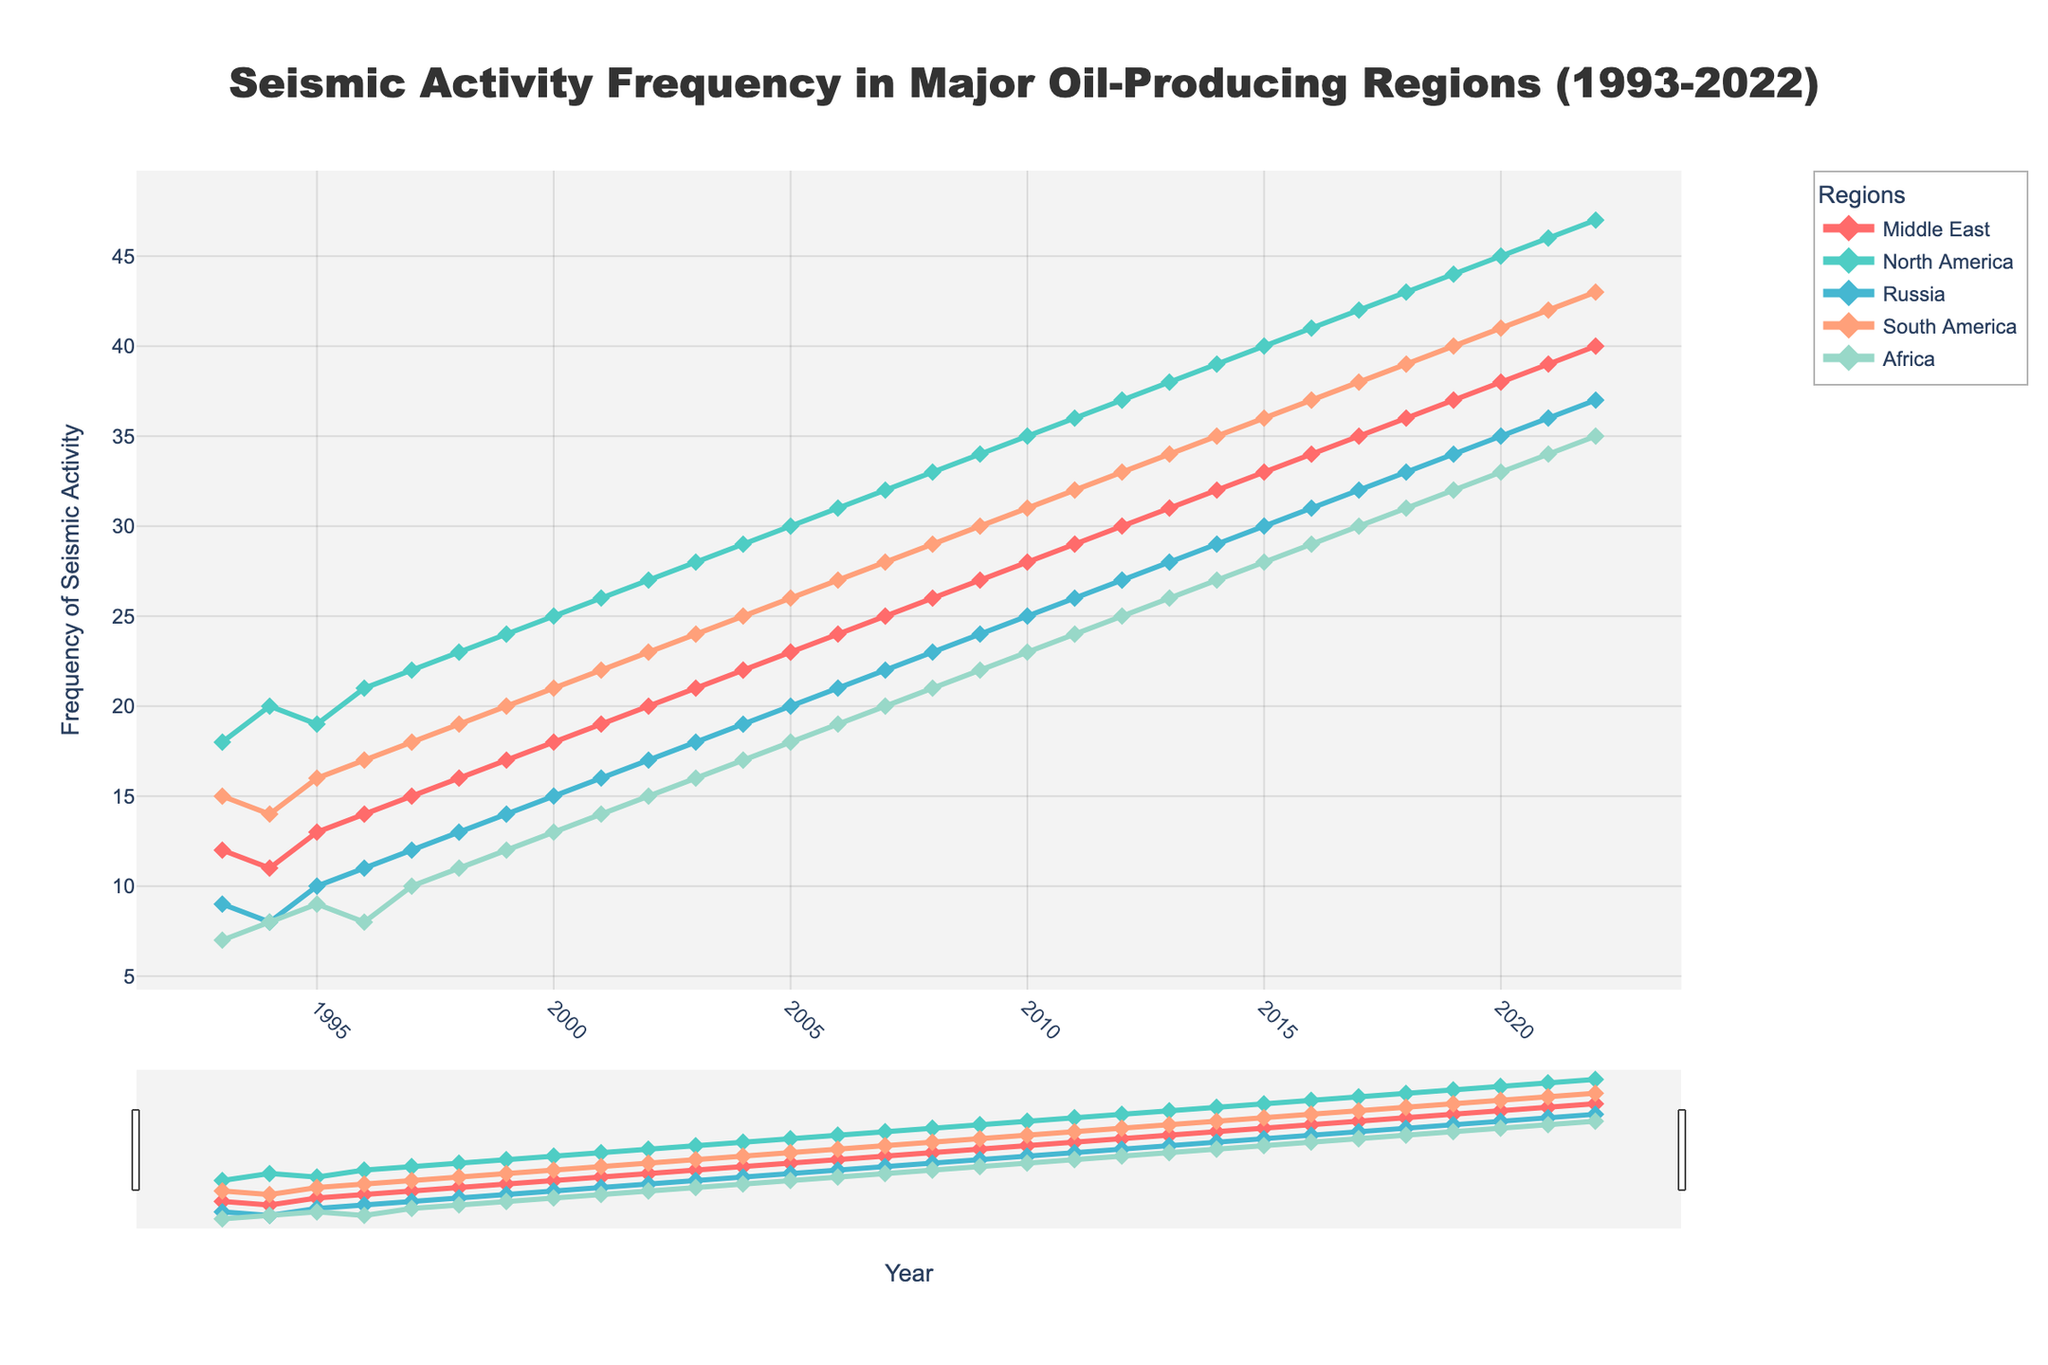Which region had the highest seismic activity in 2022? In the figure, observe the values for each region in the year 2022. The line representing North America is the highest point on the y-axis among all regions for the year 2022.
Answer: North America What is the overall trend in seismic activity in the Middle East from 1993 to 2022? Look at the line representing the Middle East. It consistently rises from 12 in 1993 to 40 in 2022, indicating an overall increasing trend.
Answer: Increasing Which two regions had the closest seismic activity frequencies in 2005? Compare the values for each region in 2005. Africa had 18, South America had 26, Middle East had 23, North America had 30, and Russia had 20. Russia and Africa had the closest values (20 and 18 respectively).
Answer: Russia and Africa By how much did the seismic activity frequency in North America increase from 1993 to 2022? In 1993, North America had a frequency of 18, and in 2022 it had 47. The increase is 47 - 18 = 29.
Answer: 29 What was the average seismic activity in Russia over the entire period from 1993 to 2022? Sum all the values for Russia and divide by the number of years (30). (9+8+10+11+12+13+14+15+16+17+18+19+20+21+22+23+24+25+26+27+28+29+30+31+32+33+34+35+36+37)/30 = 23.
Answer: 23 In which year did South America see the first major increase in seismic activity? Observe the plotted line for South America. The first noticeable increase occurs between 1994 (14) and 1995 (16), making 1995 the first major increase year.
Answer: 1995 How does the seismic activity in Africa in 2000 compare to that in 2020? The value for Africa in 2000 is 13, and in 2020 it is 33. The seismic activity increased from 13 to 33.
Answer: Increased Which region shows the most stable trend in seismic activity over the 30 years? Look at the lines for fluctuations. The line for Russia shows the smoothest, most stable increase, without sharp peaks or drops, compared to other regions.
Answer: Russia What is the sum of seismic activity frequencies for the Middle East and North America in 2010? For the Middle East in 2010, the frequency is 28 and for North America, it is 35. The sum is 28 + 35 = 63.
Answer: 63 